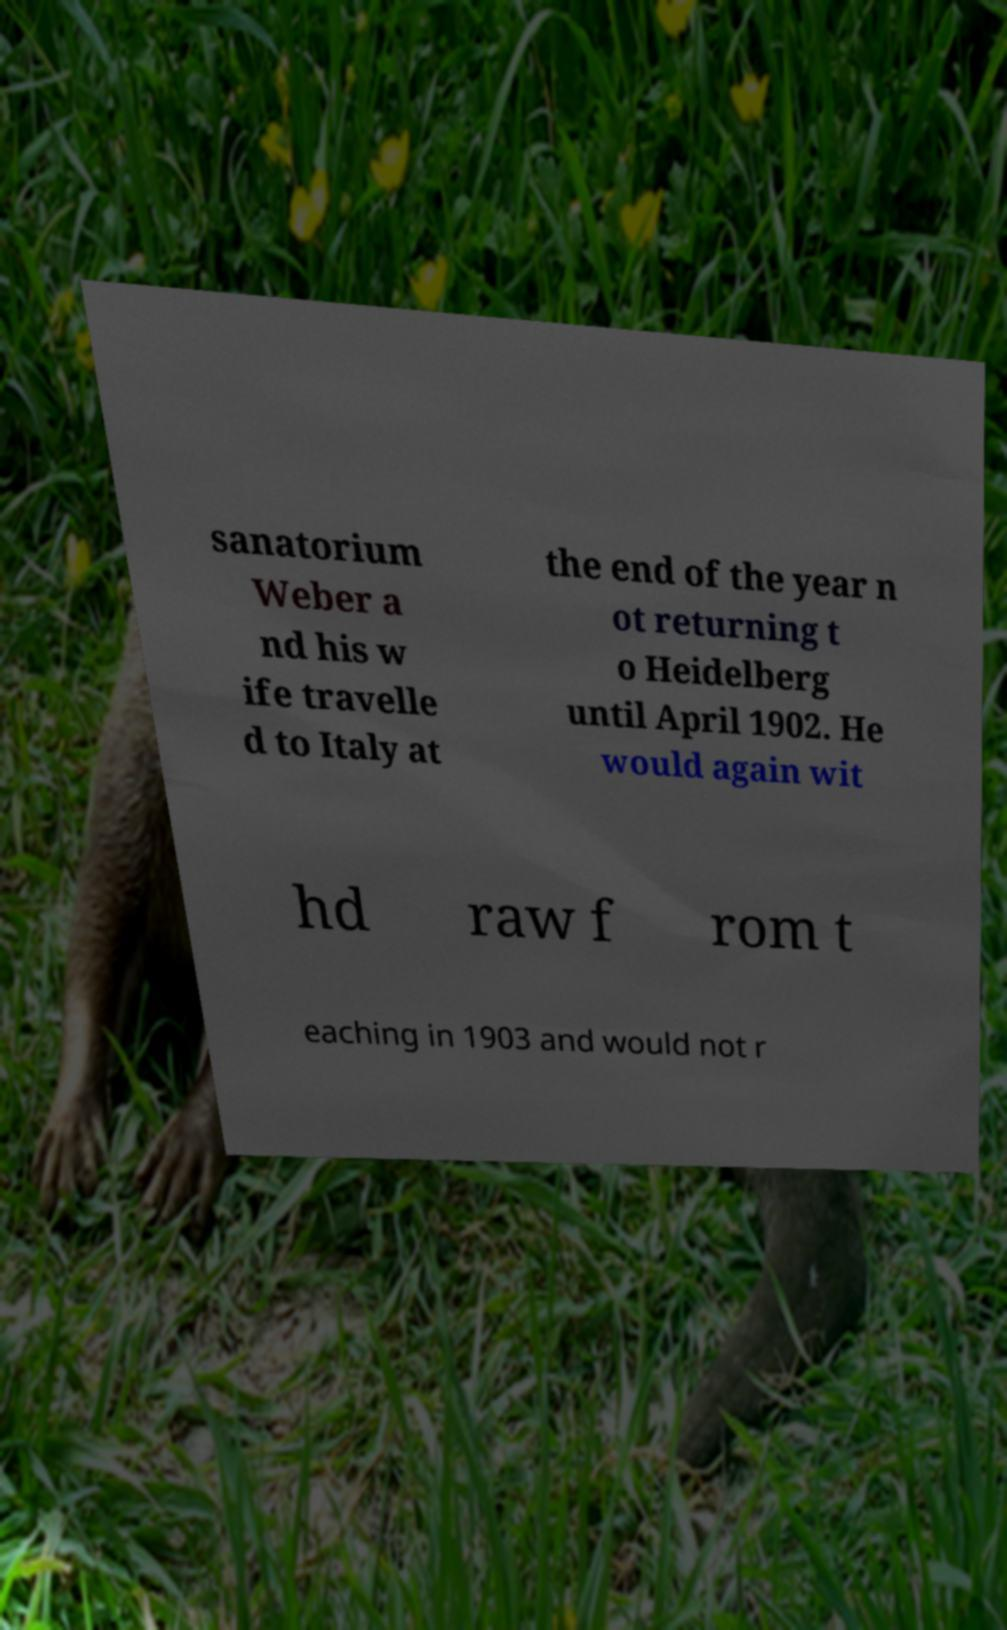Please read and relay the text visible in this image. What does it say? sanatorium Weber a nd his w ife travelle d to Italy at the end of the year n ot returning t o Heidelberg until April 1902. He would again wit hd raw f rom t eaching in 1903 and would not r 